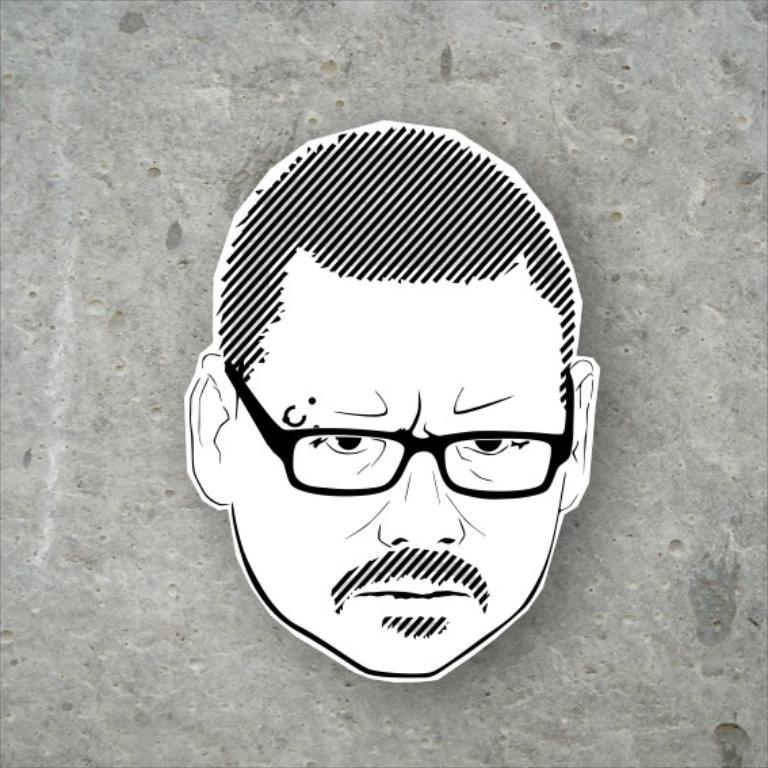What is the main subject of the image? The main subject of the image is a person's face. What accessory is the person wearing in the image? The person is wearing glasses (specs) in the image. How is the person's face depicted in the image? The person's face is drawn in the image. What can be seen in the background of the image? There is a wall visible in the image. What type of trousers is the person wearing in the image? There is no information about the person's trousers in the image, as only their face is visible. 